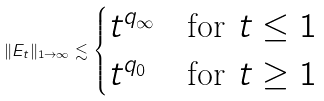Convert formula to latex. <formula><loc_0><loc_0><loc_500><loc_500>\| E _ { t } \| _ { 1 \to \infty } \lesssim \begin{cases} t ^ { q _ { \infty } } & \text {for $t \leq 1$} \\ t ^ { q _ { 0 } } & \text {for $t \geq 1$} \end{cases}</formula> 